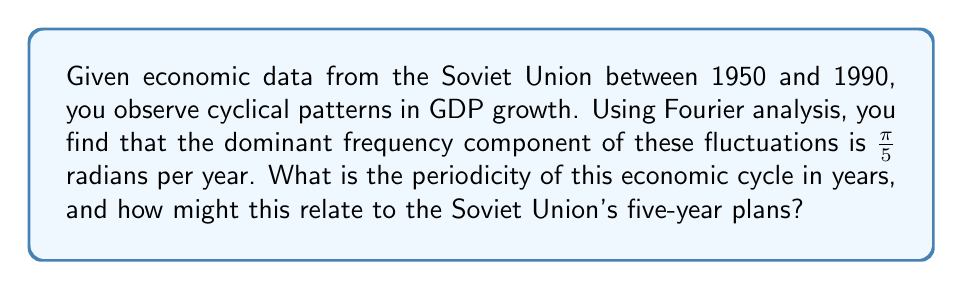What is the answer to this math problem? To solve this problem, we need to understand the relationship between frequency and period in Fourier analysis, and then interpret the result in the context of Soviet economic history.

1) In Fourier analysis, the relationship between frequency ($f$) and period ($T$) is:

   $$T = \frac{2\pi}{f}$$

2) We are given the frequency in radians per year: $f = \frac{\pi}{5}$ rad/year

3) Let's substitute this into our equation:

   $$T = \frac{2\pi}{\frac{\pi}{5}} = 2\pi \cdot \frac{5}{\pi} = 10 \text{ years}$$

4) Interpretation: The dominant economic cycle has a period of 10 years.

5) Historical context: The Soviet Union famously used five-year plans (пятилетки) to guide economic development. The 10-year cycle we've discovered suggests that the effects of these plans might have been observable over a two-plan (10-year) period.

6) This could indicate that:
   - It took two five-year plans for economic changes to fully manifest.
   - There was a lag between policy implementation and economic impact.
   - Economic adjustments made in response to one plan's outcomes might have only become fully effective during the next plan.

This analysis provides a quantitative basis for examining the effectiveness and impact of Soviet economic planning, bridging mathematical analysis with historical economic data.
Answer: The periodicity of the dominant economic cycle is 10 years. This aligns with two Soviet five-year plan cycles, suggesting a potential relationship between the observed economic fluctuations and the Soviet Union's economic planning system. 